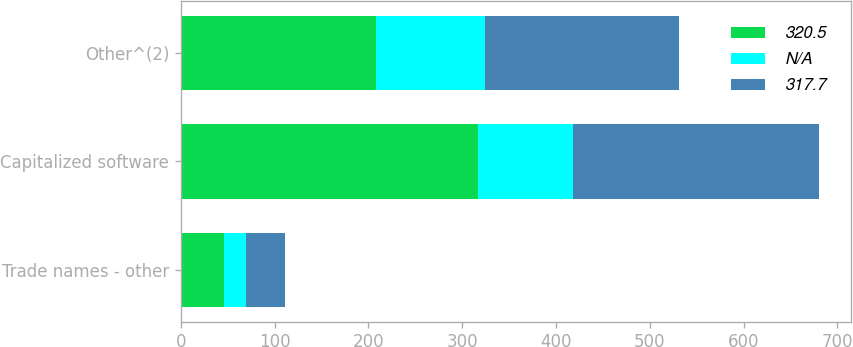<chart> <loc_0><loc_0><loc_500><loc_500><stacked_bar_chart><ecel><fcel>Trade names - other<fcel>Capitalized software<fcel>Other^(2)<nl><fcel>320.5<fcel>46.2<fcel>317.2<fcel>207.6<nl><fcel>nan<fcel>23.2<fcel>100.8<fcel>116.4<nl><fcel>317.7<fcel>41.6<fcel>262.9<fcel>206.7<nl></chart> 